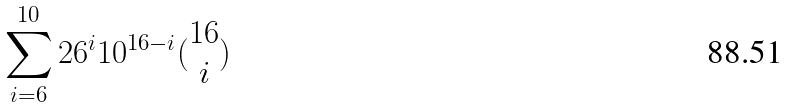<formula> <loc_0><loc_0><loc_500><loc_500>\sum _ { i = 6 } ^ { 1 0 } 2 6 ^ { i } 1 0 ^ { 1 6 - i } ( \begin{matrix} 1 6 \\ i \end{matrix} )</formula> 